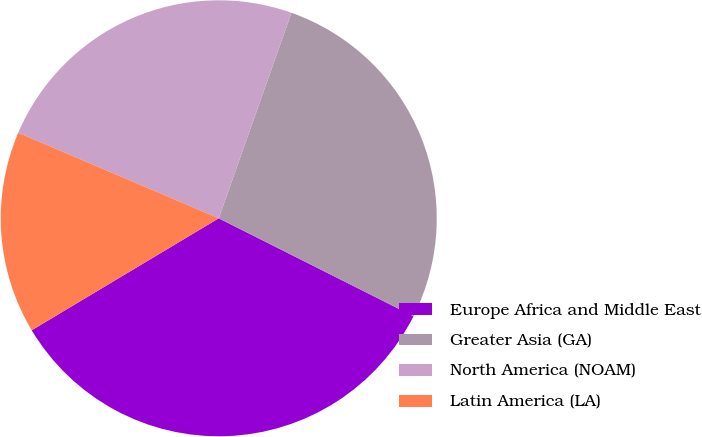<chart> <loc_0><loc_0><loc_500><loc_500><pie_chart><fcel>Europe Africa and Middle East<fcel>Greater Asia (GA)<fcel>North America (NOAM)<fcel>Latin America (LA)<nl><fcel>34.0%<fcel>27.0%<fcel>24.0%<fcel>15.0%<nl></chart> 